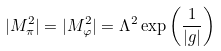<formula> <loc_0><loc_0><loc_500><loc_500>| M _ { \pi } ^ { 2 } | = | M _ { \varphi } ^ { 2 } | = \Lambda ^ { 2 } \exp \left ( \frac { 1 } { | g | } \right )</formula> 